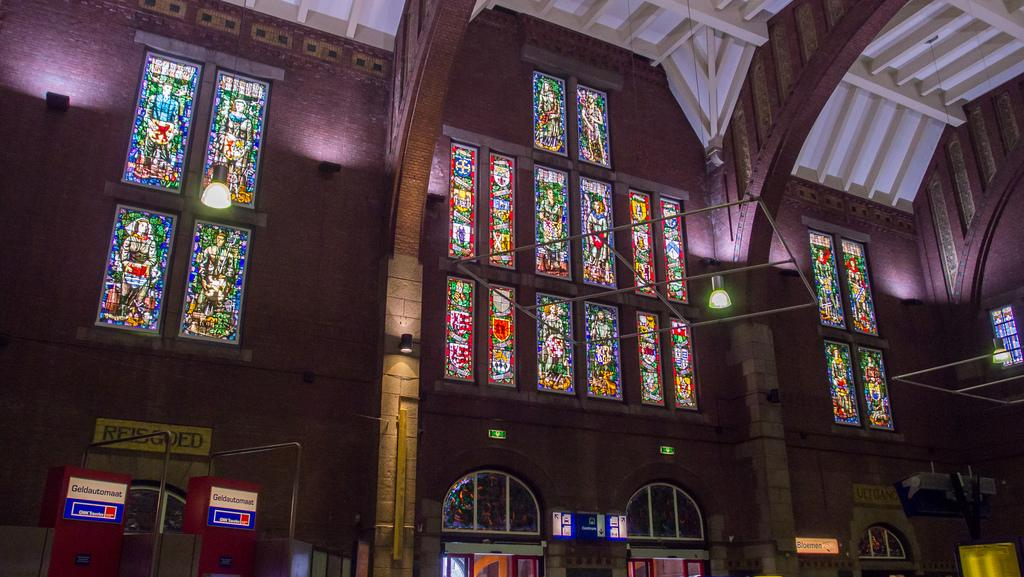What type of structure is visible in the image? There is a building in the image. What feature can be observed on the building's windows? The building has glass windows with stained glasses attached to them. What is present on the ceiling of the building? There are lights attached to the ceiling. What type of pencil is being used to make a selection in the image? There is no pencil or selection process visible in the image; it only features a building with glass windows and stained glasses, as well as lights attached to the ceiling. 